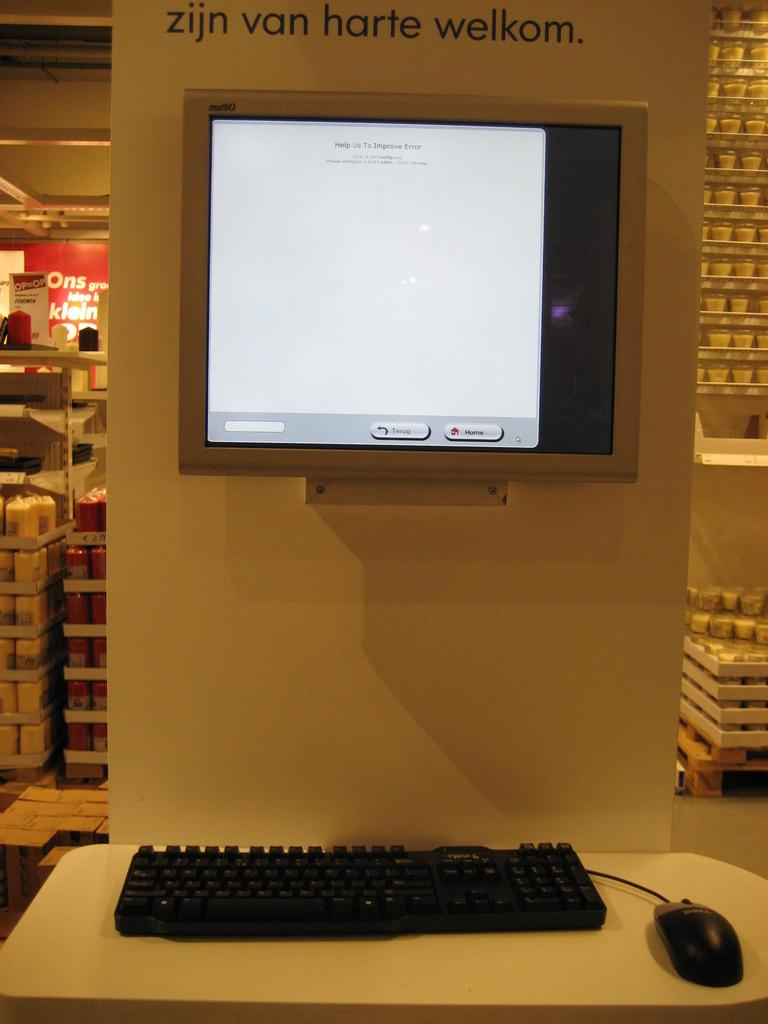<image>
Share a concise interpretation of the image provided. a screen on a wall that's underneath a label that says 'zijn van harte welkom' 